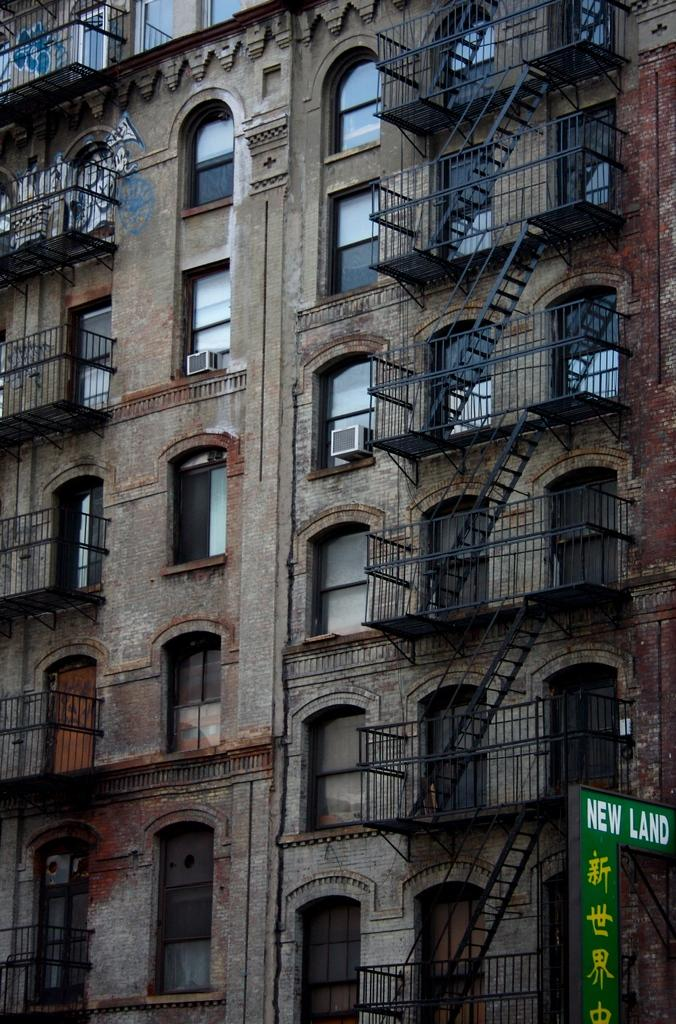What is the main subject in the center of the image? There is a building in the center of the image. What features can be observed on the building? The building has windows and railings. What is located to the left side of the image? There is an advertisement board to the left side of the image. What can be seen on the advertisement board? The advertisement board has some text on it. Can you tell me what the doctor is doing downtown in the image? There is no doctor or downtown location present in the image; it features a building with an advertisement board. 